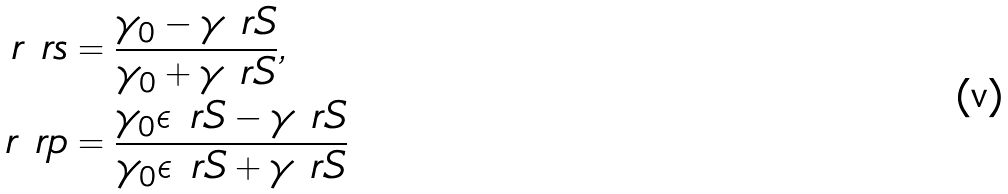<formula> <loc_0><loc_0><loc_500><loc_500>r _ { \ } r s & = \frac { \gamma _ { 0 } - \gamma _ { \ } r S } { \gamma _ { 0 } + \gamma _ { \ } r S } , \\ r _ { \ } r p & = \frac { \gamma _ { 0 } \epsilon _ { \ } r S - \gamma _ { \ } r S } { \gamma _ { 0 } \epsilon _ { \ } r S + \gamma _ { \ } r S }</formula> 